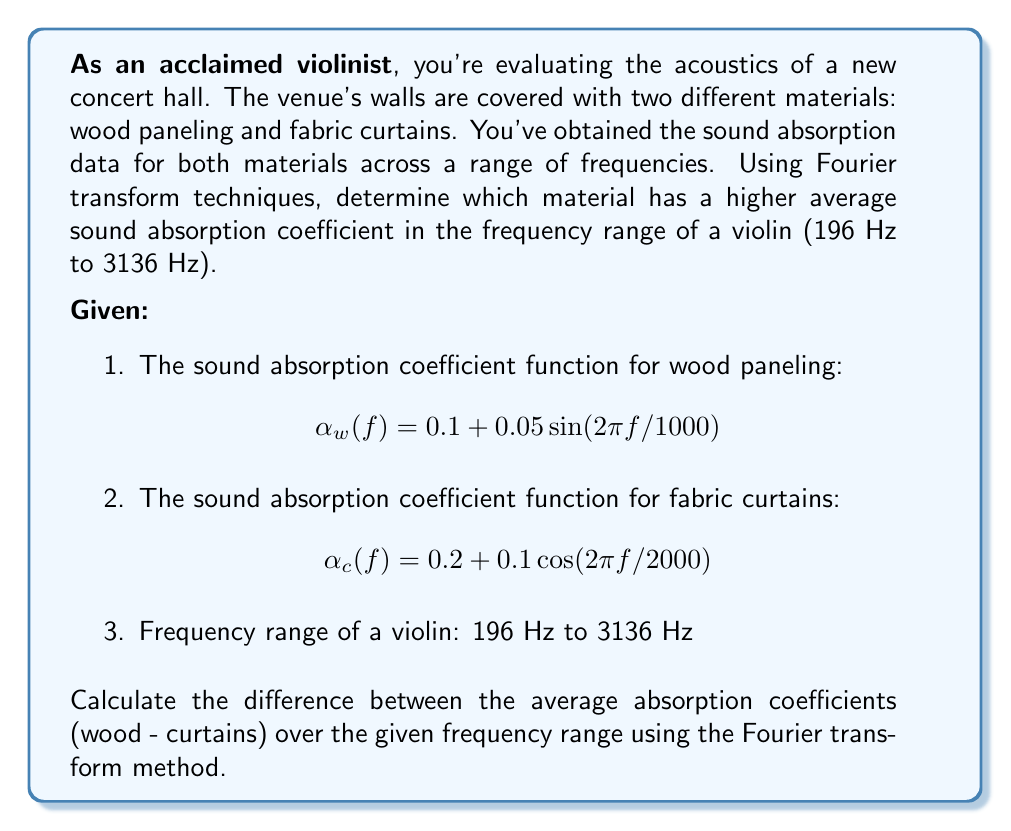Help me with this question. To solve this problem, we'll follow these steps:

1) First, we need to calculate the average absorption coefficient for each material over the given frequency range. We can do this using the Fourier transform.

2) The average value of a function over an interval [a,b] is given by:

   $$\bar{\alpha} = \frac{1}{b-a} \int_a^b \alpha(f) df$$

3) We can calculate this integral using the Fourier transform property:

   $$\int_a^b \alpha(f) df = \frac{b-a}{2\pi} \cdot \hat{\alpha}(0)$$

   where $\hat{\alpha}(0)$ is the Fourier transform of $\alpha(f)$ evaluated at 0.

4) For wood paneling:
   $$\alpha_w(f) = 0.1 + 0.05 \sin(2\pi f/1000)$$
   
   The Fourier transform of a constant is itself, and the transform of $\sin(2\pi f/T)$ at 0 is 0.
   
   So, $\hat{\alpha_w}(0) = 0.1$

5) For fabric curtains:
   $$\alpha_c(f) = 0.2 + 0.1 \cos(2\pi f/2000)$$
   
   The Fourier transform of $\cos(2\pi f/T)$ at 0 is 1.
   
   So, $\hat{\alpha_c}(0) = 0.2 + 0.1 = 0.3$

6) Now we can calculate the average absorption coefficients:

   For wood: $\bar{\alpha_w} = 0.1$
   For curtains: $\bar{\alpha_c} = 0.3$

7) The difference (wood - curtains) is:

   $$0.1 - 0.3 = -0.2$$
Answer: -0.2 